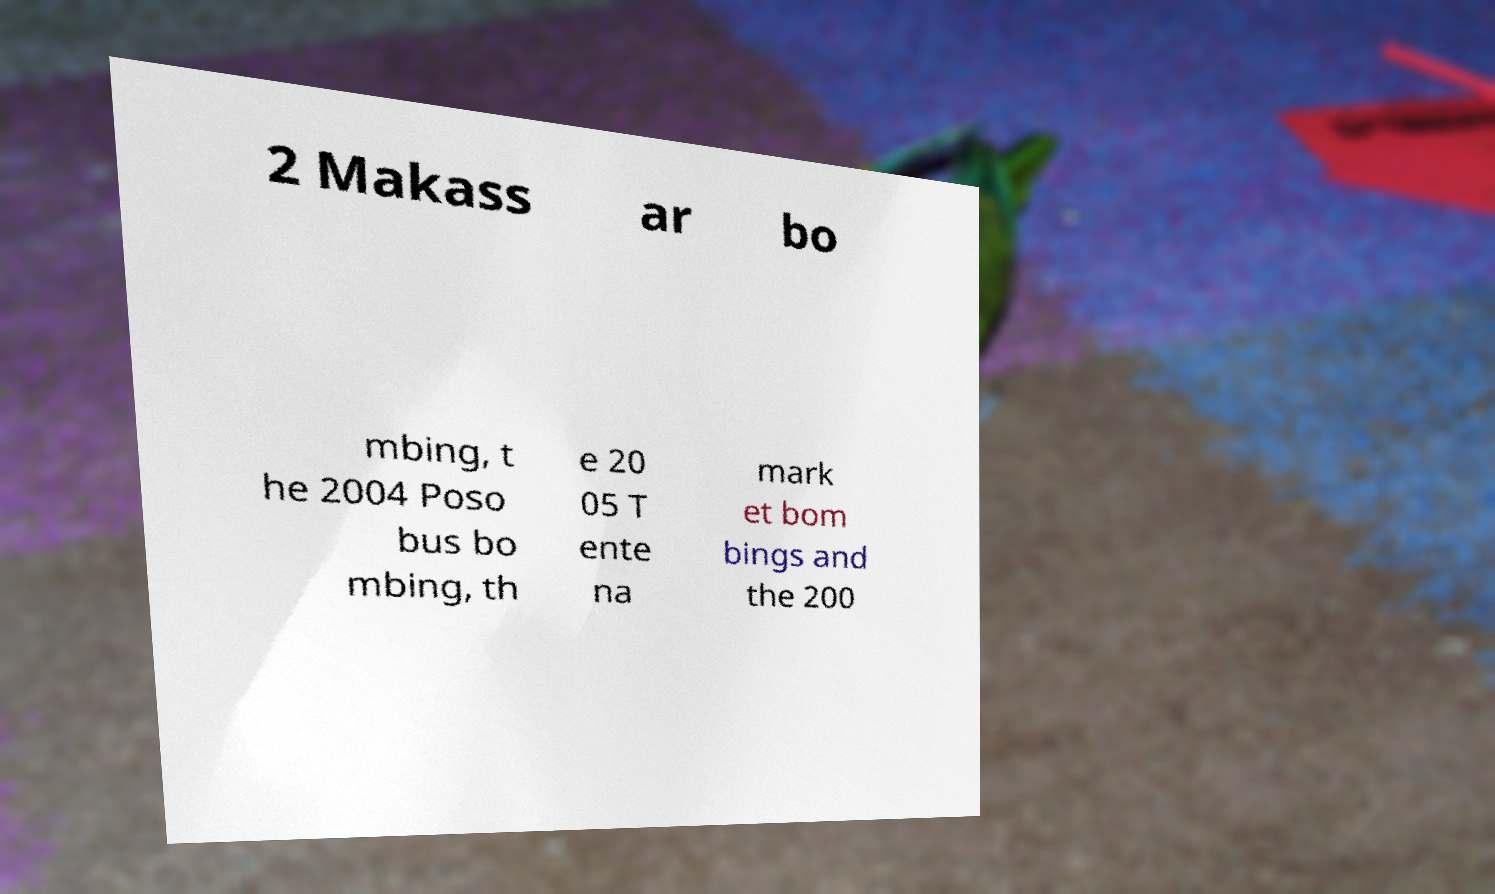Please read and relay the text visible in this image. What does it say? 2 Makass ar bo mbing, t he 2004 Poso bus bo mbing, th e 20 05 T ente na mark et bom bings and the 200 